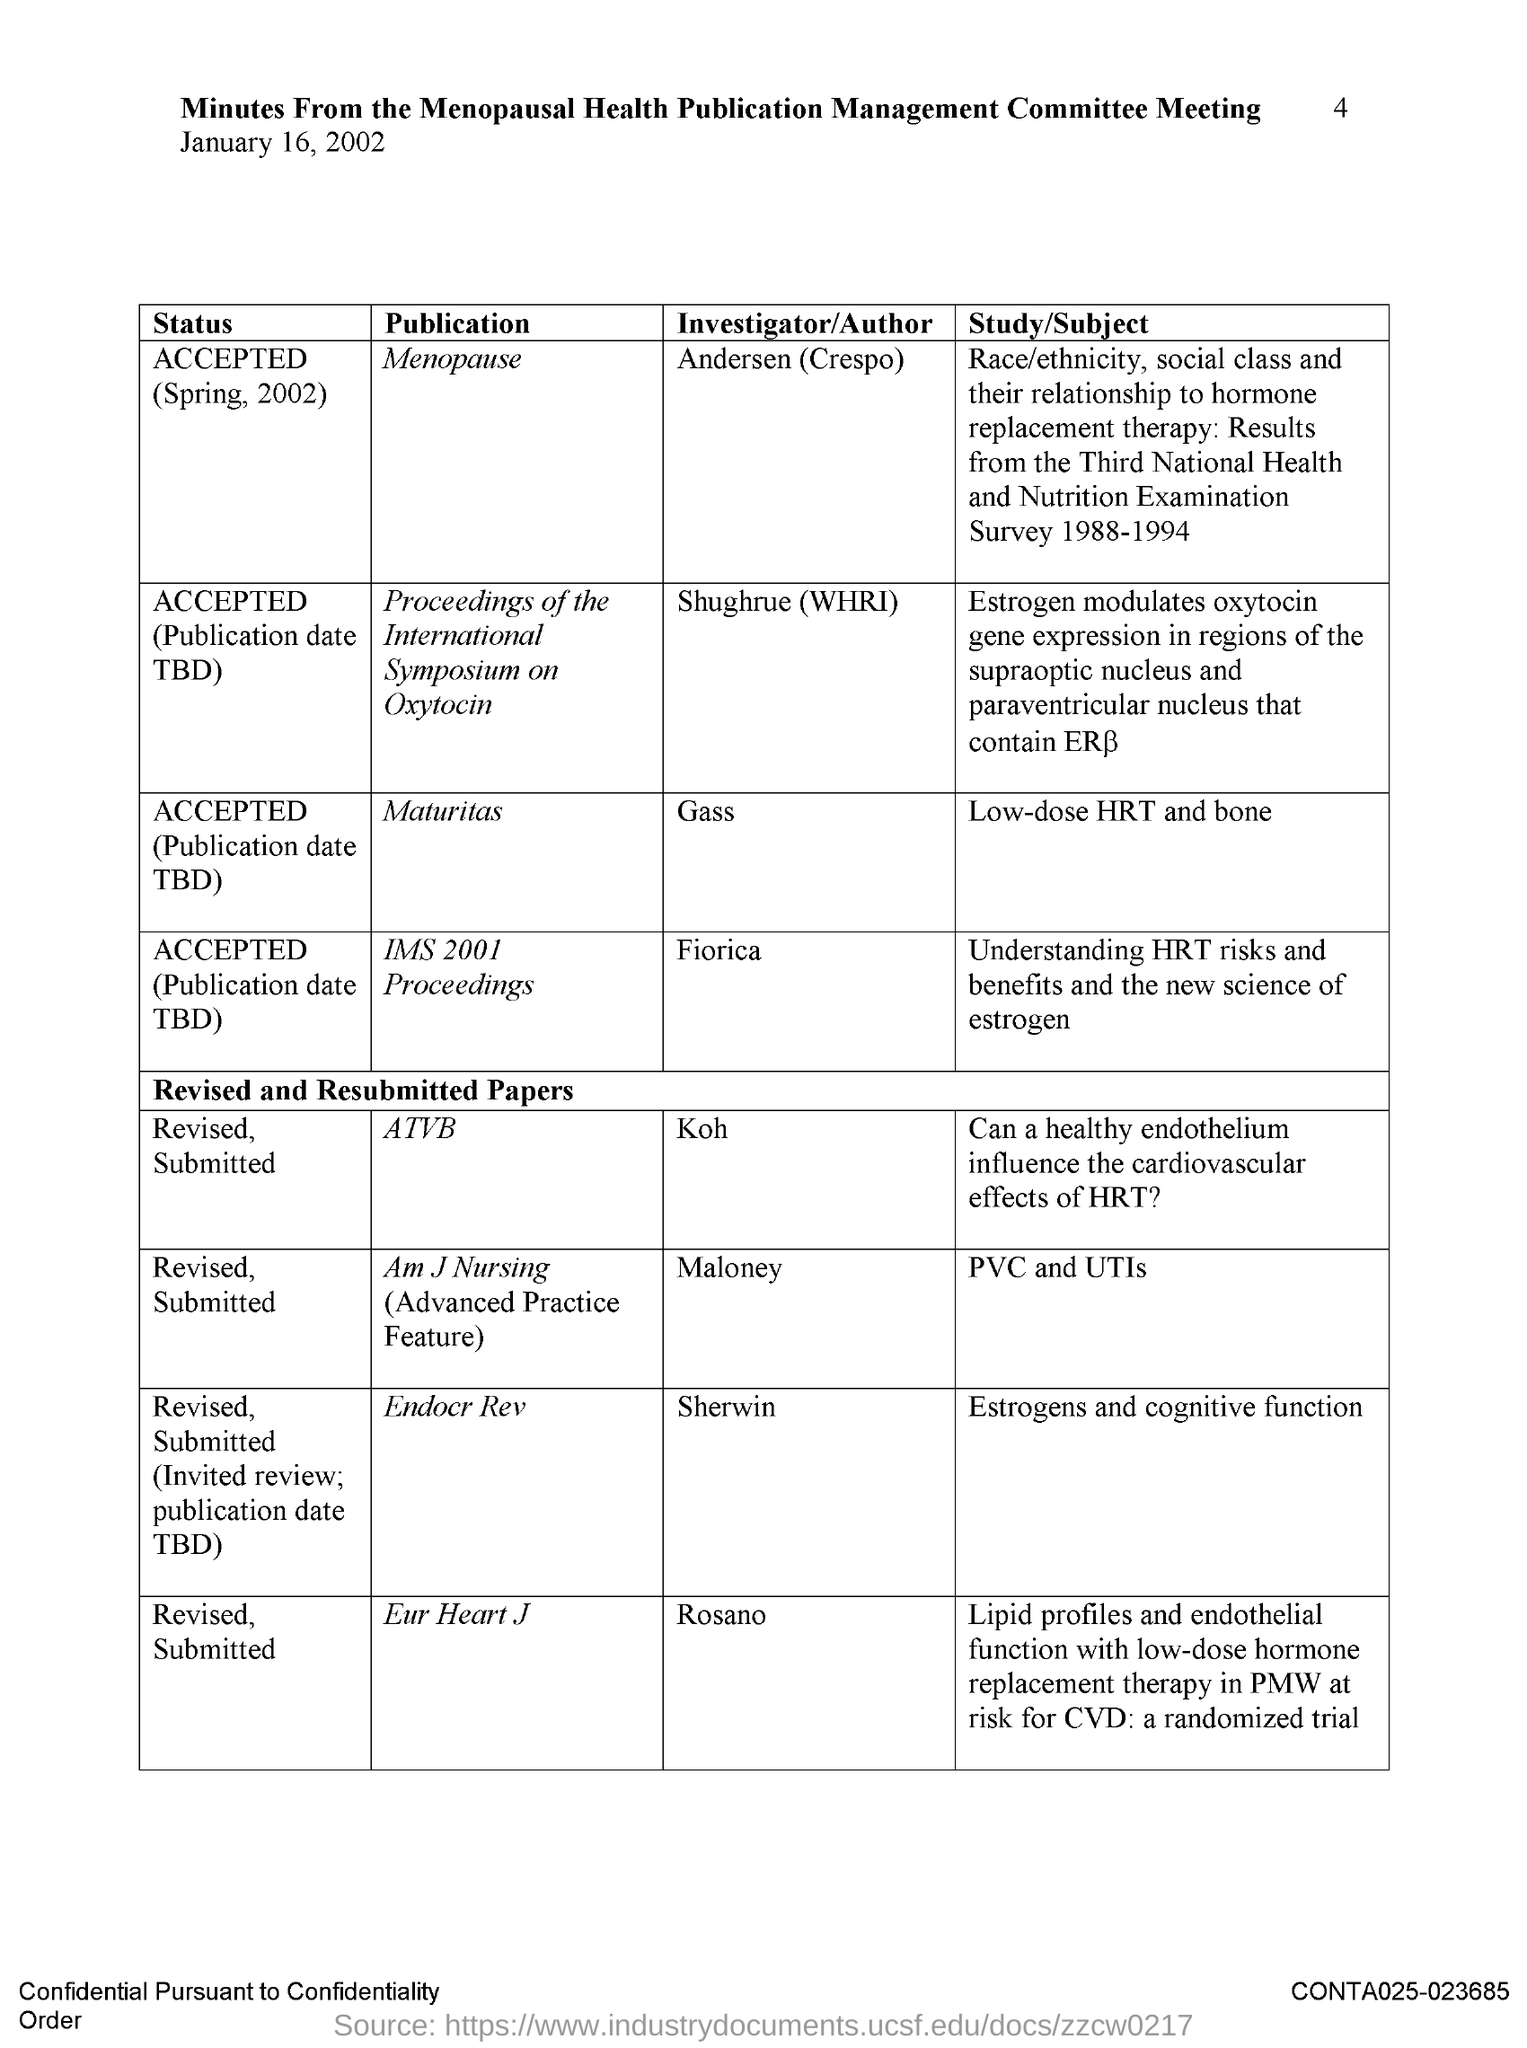What is the Page Number?
Keep it short and to the point. 4. What is the title of the document?
Provide a short and direct response. Minutes from the menopausal health publication management committee meeting. What is the date mentioned in the document?
Your answer should be compact. January 16, 2002. Who is the author of the publication "Maturitas"?
Offer a terse response. Gass. Who is the author of the publication "ATVB"?
Your response must be concise. Koh. Who is the author of the publication "Endocr Rev"?
Your answer should be compact. Sherwin. Who is the author of the publication "Eur Heart J"?
Offer a terse response. Rosano. 